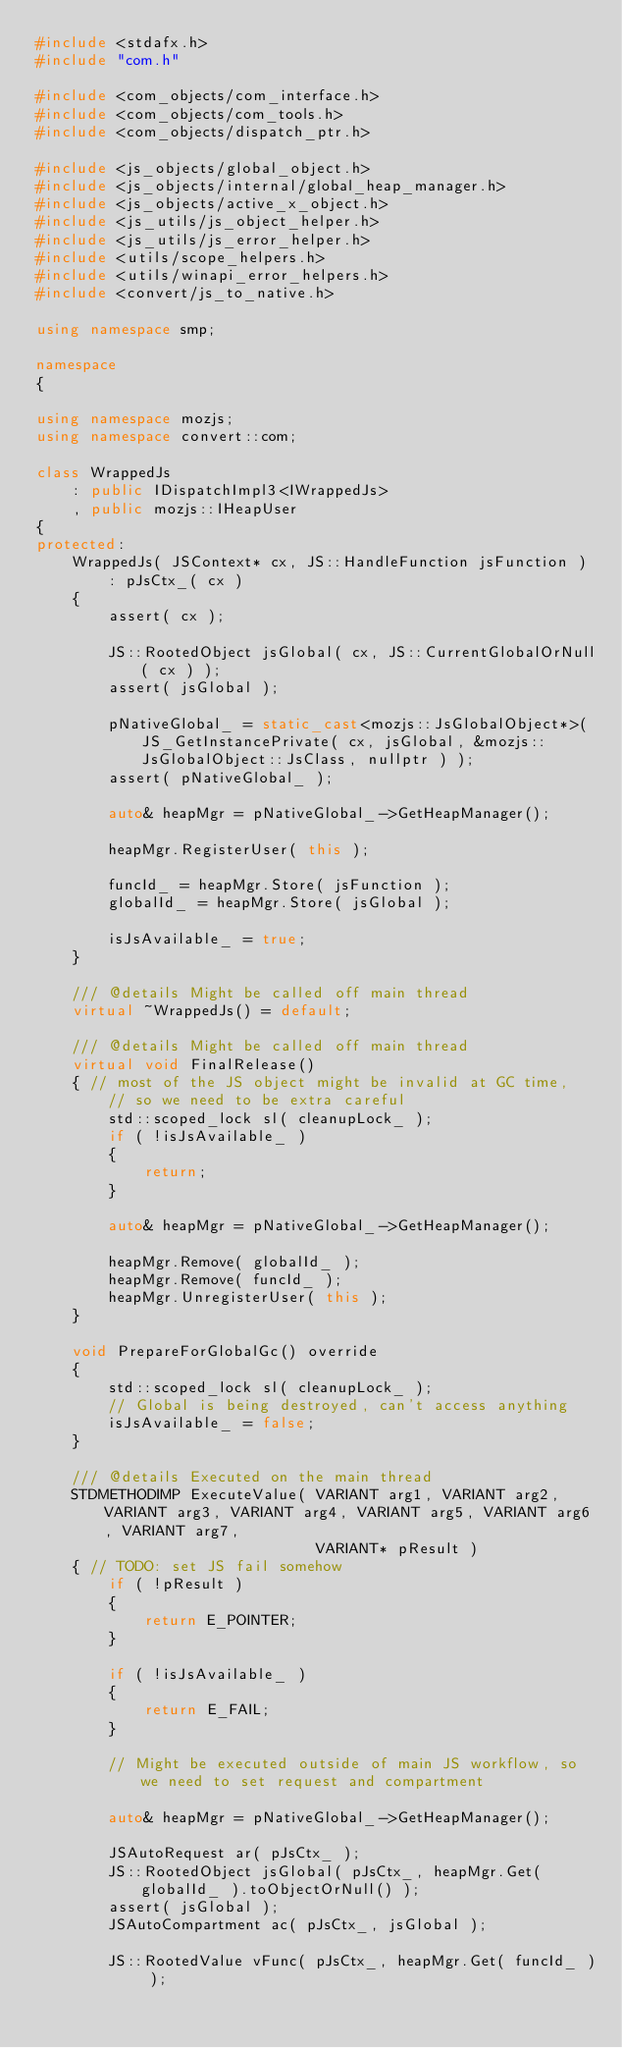Convert code to text. <code><loc_0><loc_0><loc_500><loc_500><_C++_>#include <stdafx.h>
#include "com.h"

#include <com_objects/com_interface.h>
#include <com_objects/com_tools.h>
#include <com_objects/dispatch_ptr.h>

#include <js_objects/global_object.h>
#include <js_objects/internal/global_heap_manager.h>
#include <js_objects/active_x_object.h>
#include <js_utils/js_object_helper.h>
#include <js_utils/js_error_helper.h>
#include <utils/scope_helpers.h>
#include <utils/winapi_error_helpers.h>
#include <convert/js_to_native.h>

using namespace smp;

namespace
{

using namespace mozjs;
using namespace convert::com;

class WrappedJs
    : public IDispatchImpl3<IWrappedJs>
    , public mozjs::IHeapUser
{
protected:
    WrappedJs( JSContext* cx, JS::HandleFunction jsFunction )
        : pJsCtx_( cx )
    {
        assert( cx );

        JS::RootedObject jsGlobal( cx, JS::CurrentGlobalOrNull( cx ) );
        assert( jsGlobal );

        pNativeGlobal_ = static_cast<mozjs::JsGlobalObject*>( JS_GetInstancePrivate( cx, jsGlobal, &mozjs::JsGlobalObject::JsClass, nullptr ) );
        assert( pNativeGlobal_ );

        auto& heapMgr = pNativeGlobal_->GetHeapManager();

        heapMgr.RegisterUser( this );

        funcId_ = heapMgr.Store( jsFunction );
        globalId_ = heapMgr.Store( jsGlobal );

        isJsAvailable_ = true;
    }

    /// @details Might be called off main thread
    virtual ~WrappedJs() = default;

    /// @details Might be called off main thread
    virtual void FinalRelease()
    { // most of the JS object might be invalid at GC time,
        // so we need to be extra careful
        std::scoped_lock sl( cleanupLock_ );
        if ( !isJsAvailable_ )
        {
            return;
        }

        auto& heapMgr = pNativeGlobal_->GetHeapManager();

        heapMgr.Remove( globalId_ );
        heapMgr.Remove( funcId_ );
        heapMgr.UnregisterUser( this );
    }

    void PrepareForGlobalGc() override
    {
        std::scoped_lock sl( cleanupLock_ );
        // Global is being destroyed, can't access anything
        isJsAvailable_ = false;
    }

    /// @details Executed on the main thread
    STDMETHODIMP ExecuteValue( VARIANT arg1, VARIANT arg2, VARIANT arg3, VARIANT arg4, VARIANT arg5, VARIANT arg6, VARIANT arg7,
                               VARIANT* pResult )
    { // TODO: set JS fail somehow
        if ( !pResult )
        {
            return E_POINTER;
        }

        if ( !isJsAvailable_ )
        {
            return E_FAIL;
        }

        // Might be executed outside of main JS workflow, so we need to set request and compartment

        auto& heapMgr = pNativeGlobal_->GetHeapManager();

        JSAutoRequest ar( pJsCtx_ );
        JS::RootedObject jsGlobal( pJsCtx_, heapMgr.Get( globalId_ ).toObjectOrNull() );
        assert( jsGlobal );
        JSAutoCompartment ac( pJsCtx_, jsGlobal );

        JS::RootedValue vFunc( pJsCtx_, heapMgr.Get( funcId_ ) );</code> 